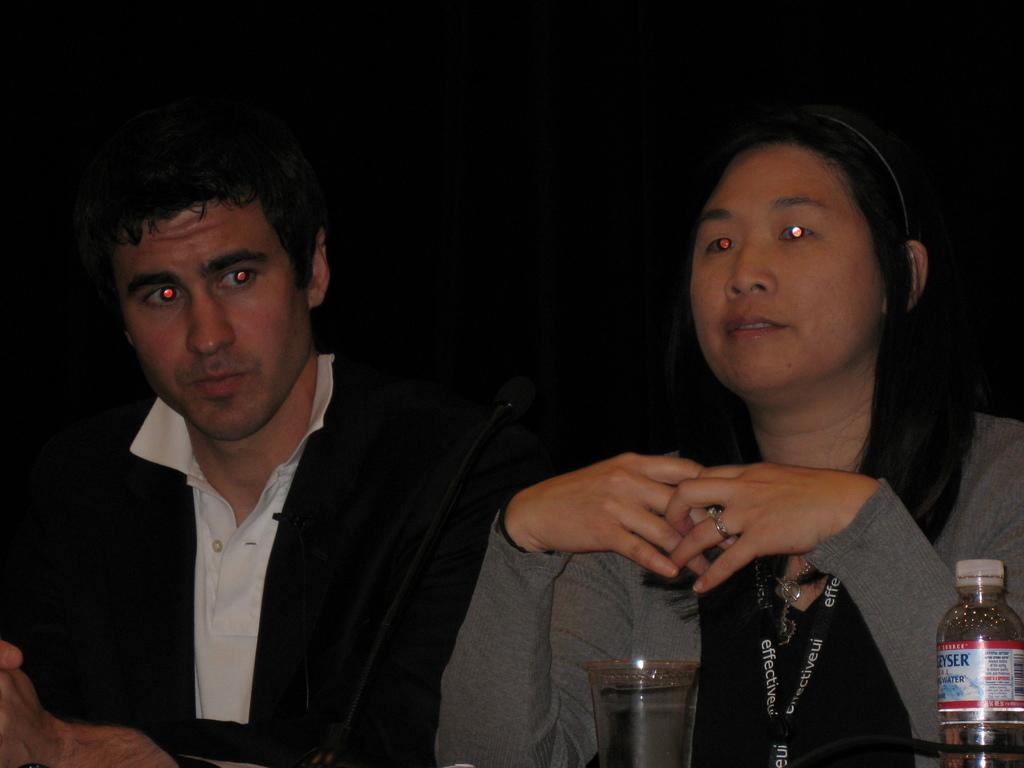How many people are present in the image? There is a man and a woman present in the image. What is the woman wearing that identifies her? The woman is wearing a tag. What objects are in front of the woman? There is a microphone, a glass, and a bottle in front of the woman. What is the lighting condition in the image? The background of the image is dark. What type of mist can be seen in the image? There is no mist present in the image. What downtown area is visible in the image? There is no downtown area visible in the image. 